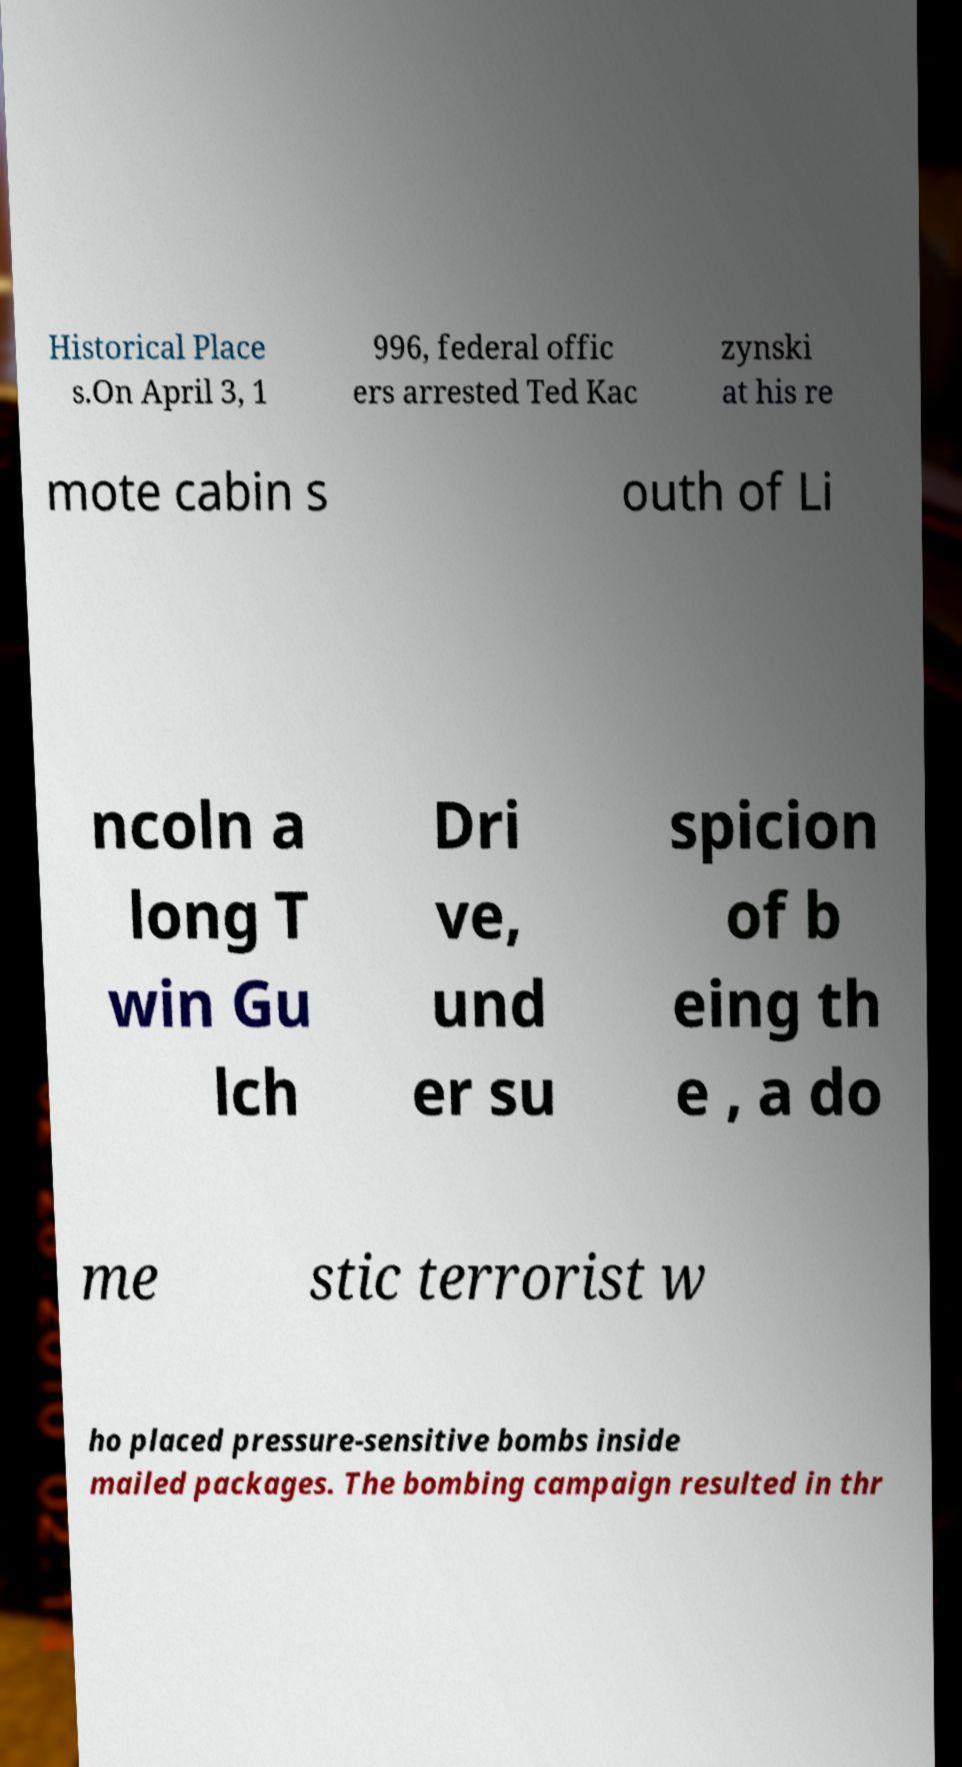There's text embedded in this image that I need extracted. Can you transcribe it verbatim? Historical Place s.On April 3, 1 996, federal offic ers arrested Ted Kac zynski at his re mote cabin s outh of Li ncoln a long T win Gu lch Dri ve, und er su spicion of b eing th e , a do me stic terrorist w ho placed pressure-sensitive bombs inside mailed packages. The bombing campaign resulted in thr 